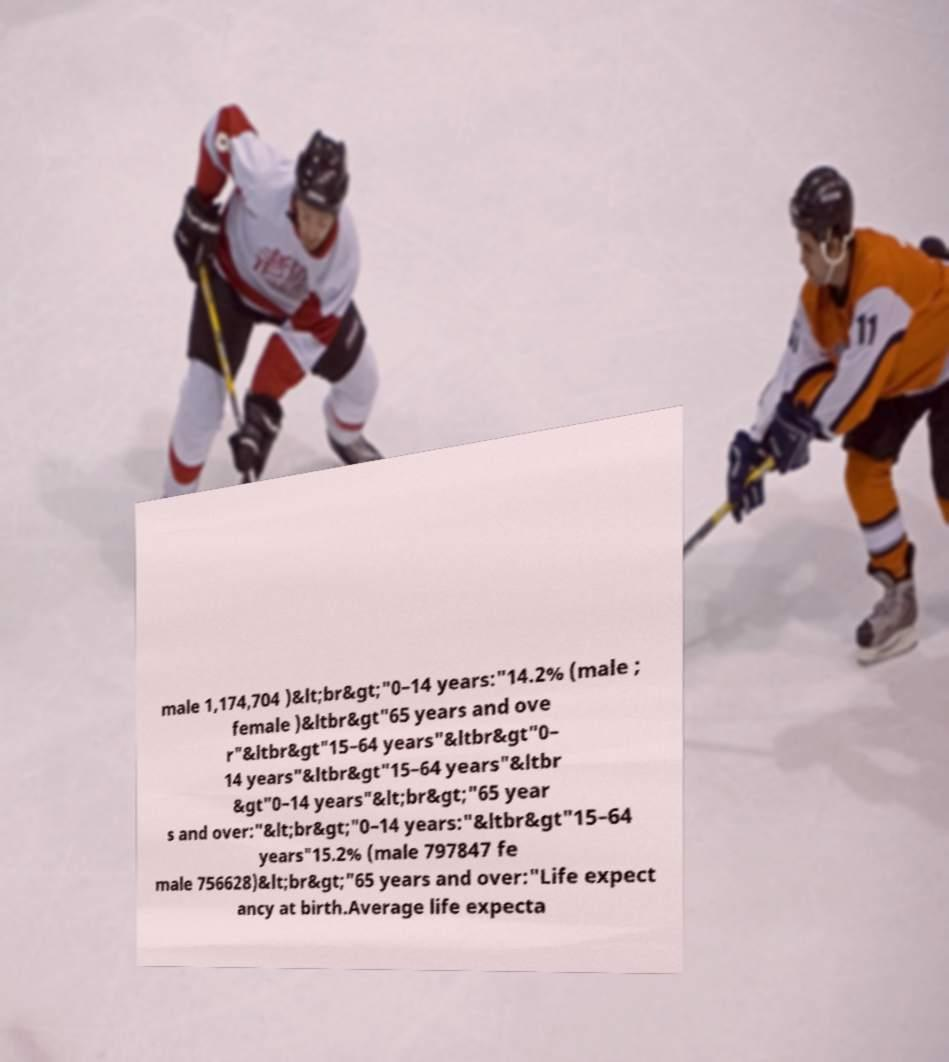Can you read and provide the text displayed in the image?This photo seems to have some interesting text. Can you extract and type it out for me? male 1,174,704 )&lt;br&gt;"0–14 years:"14.2% (male ; female )&ltbr&gt"65 years and ove r"&ltbr&gt"15–64 years"&ltbr&gt"0– 14 years"&ltbr&gt"15–64 years"&ltbr &gt"0–14 years"&lt;br&gt;"65 year s and over:"&lt;br&gt;"0–14 years:"&ltbr&gt"15–64 years"15.2% (male 797847 fe male 756628)&lt;br&gt;"65 years and over:"Life expect ancy at birth.Average life expecta 